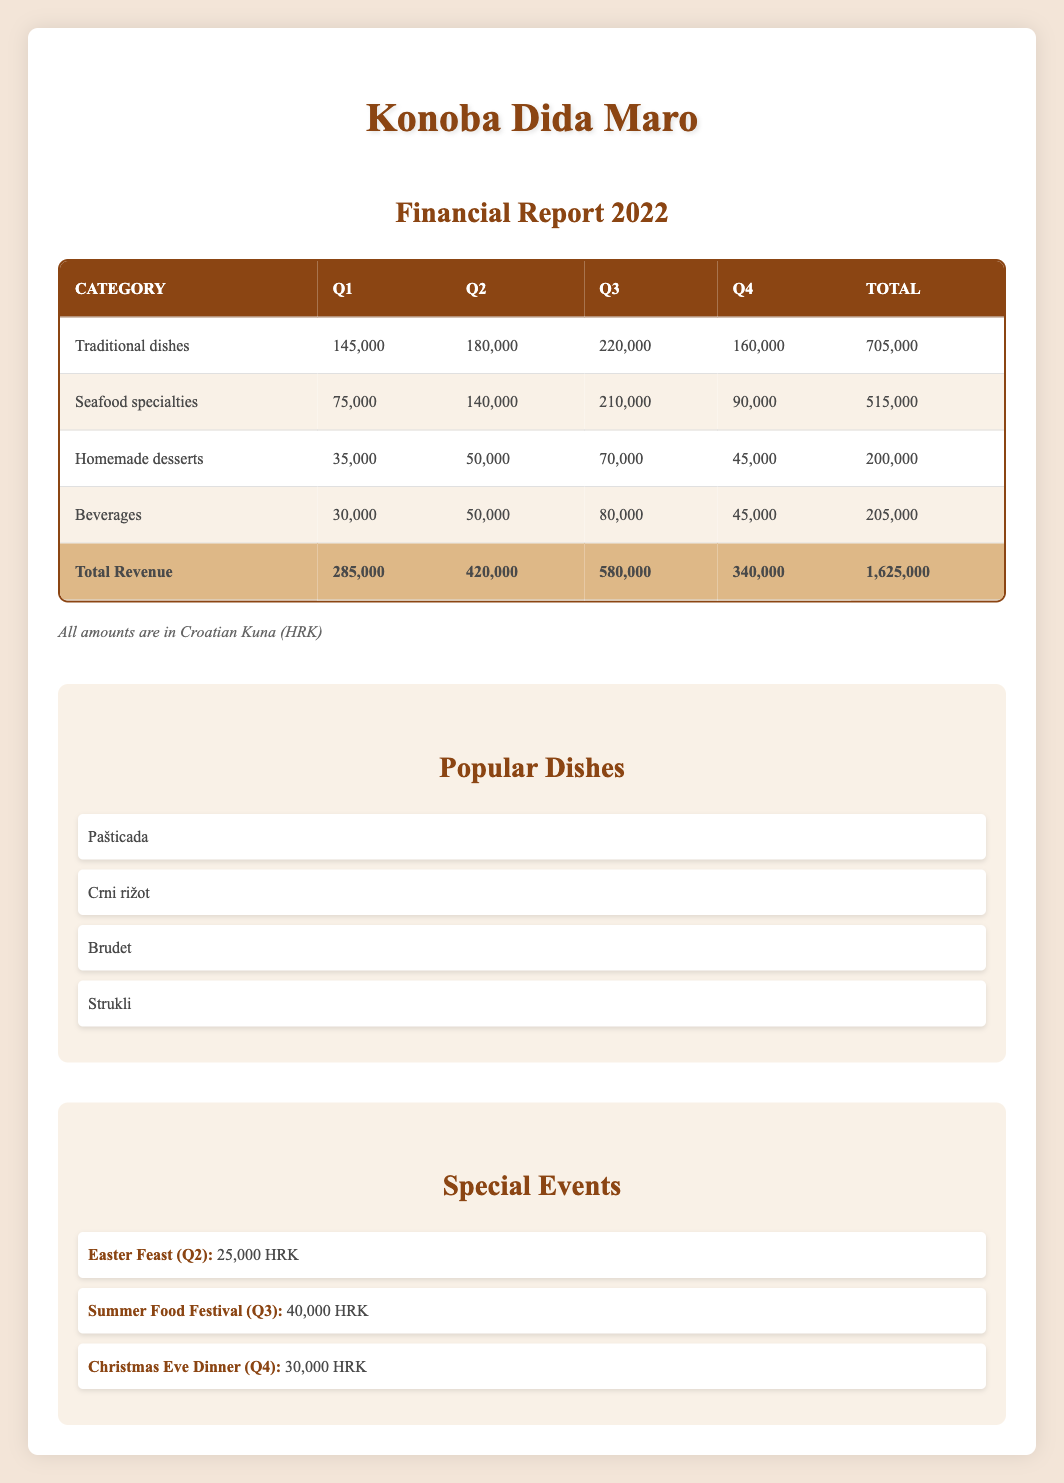What was the total revenue for Q3? The table shows that the total revenue for Q3 is explicitly listed. According to the data in the last row of the table, it is 580,000 HRK.
Answer: 580,000 HRK Which category had the highest revenue in Q2? By comparing the amounts in Q2 for each category listed in the table, Traditional dishes had 180,000 HRK while Seafood specialties had 140,000 HRK, Homemade desserts had 50,000 HRK, and Beverages had 50,000 HRK. Therefore, Traditional dishes, with 180,000 HRK, was the highest.
Answer: Traditional dishes What is the total revenue from Homemade desserts for the entire year? To find the total revenue from Homemade desserts, we need to sum the amounts from all four quarters: 35,000 (Q1) + 50,000 (Q2) + 70,000 (Q3) + 45,000 (Q4) = 200,000 HRK.
Answer: 200,000 HRK Is the revenue from Seafood specialties in Q4 more than that in Q1? Q4 revenue for Seafood specialties is 90,000 HRK, while Q1 revenue is only 75,000 HRK. Comparing the two, 90,000 HRK is more than 75,000 HRK, so the answer is yes.
Answer: Yes What is the average revenue from Traditional dishes across all quarters? To calculate the average revenue from Traditional dishes, we first sum the revenues from each quarter: 145,000 (Q1) + 180,000 (Q2) + 220,000 (Q3) + 160,000 (Q4) = 705,000 HRK. There are four quarters, so we divide the total (705,000) by 4 to find the average, which equals 176,250 HRK.
Answer: 176,250 HRK Which quarter had the highest total revenue? Looking at the total revenue for each quarter: Q1 is 285,000 HRK, Q2 is 420,000 HRK, Q3 is 580,000 HRK, and Q4 is 340,000 HRK. Clearly, Q3 had the highest total revenue at 580,000 HRK.
Answer: Q3 Was the revenue from special events higher in Q3 or Q4? For Q3, the Summer Food Festival brought in 40,000 HRK, whereas for Q4, the Christmas Eve Dinner generated 30,000 HRK. Since 40,000 is greater than 30,000, the answer is that Q3 had higher revenue from special events.
Answer: Q3 What is the total revenue for the entire year? The total revenue for the year is determined by adding the total revenue for each quarter: 285,000 (Q1) + 420,000 (Q2) + 580,000 (Q3) + 340,000 (Q4) = 1,625,000 HRK. This total is specified in the final row of the table.
Answer: 1,625,000 HRK 